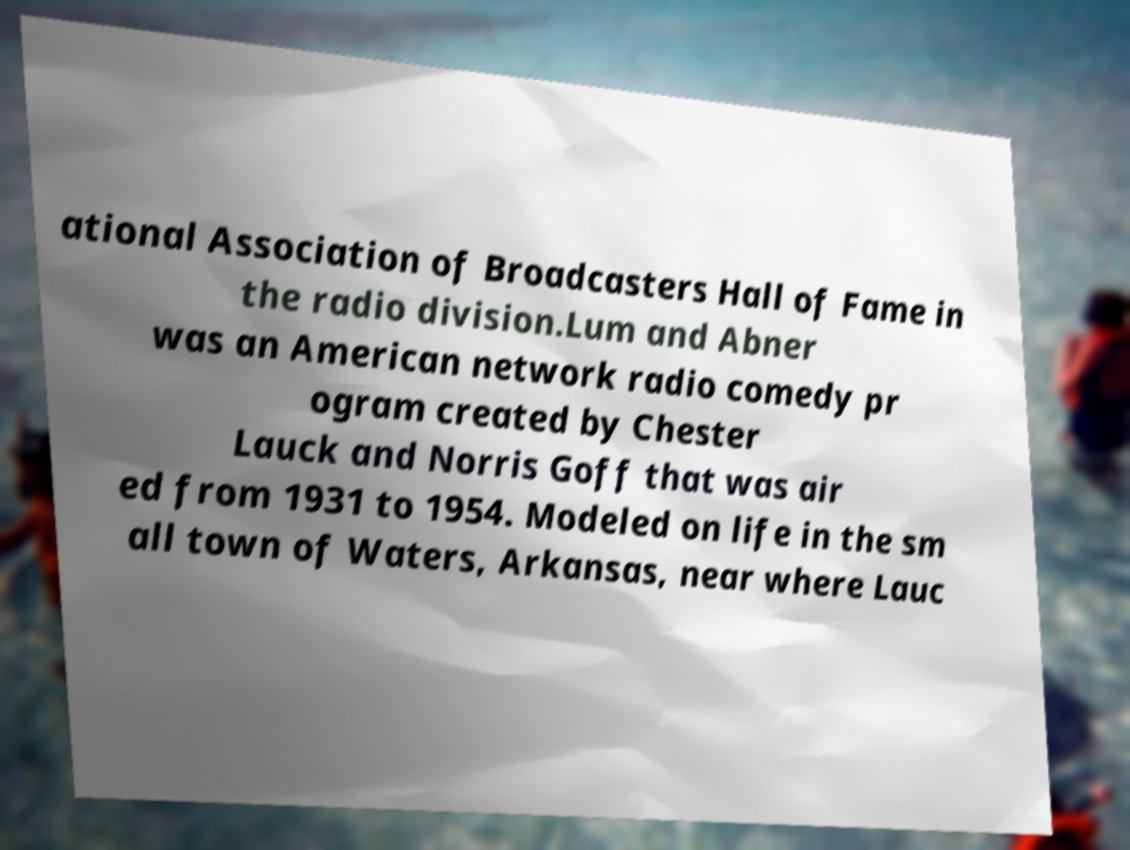Can you accurately transcribe the text from the provided image for me? ational Association of Broadcasters Hall of Fame in the radio division.Lum and Abner was an American network radio comedy pr ogram created by Chester Lauck and Norris Goff that was air ed from 1931 to 1954. Modeled on life in the sm all town of Waters, Arkansas, near where Lauc 